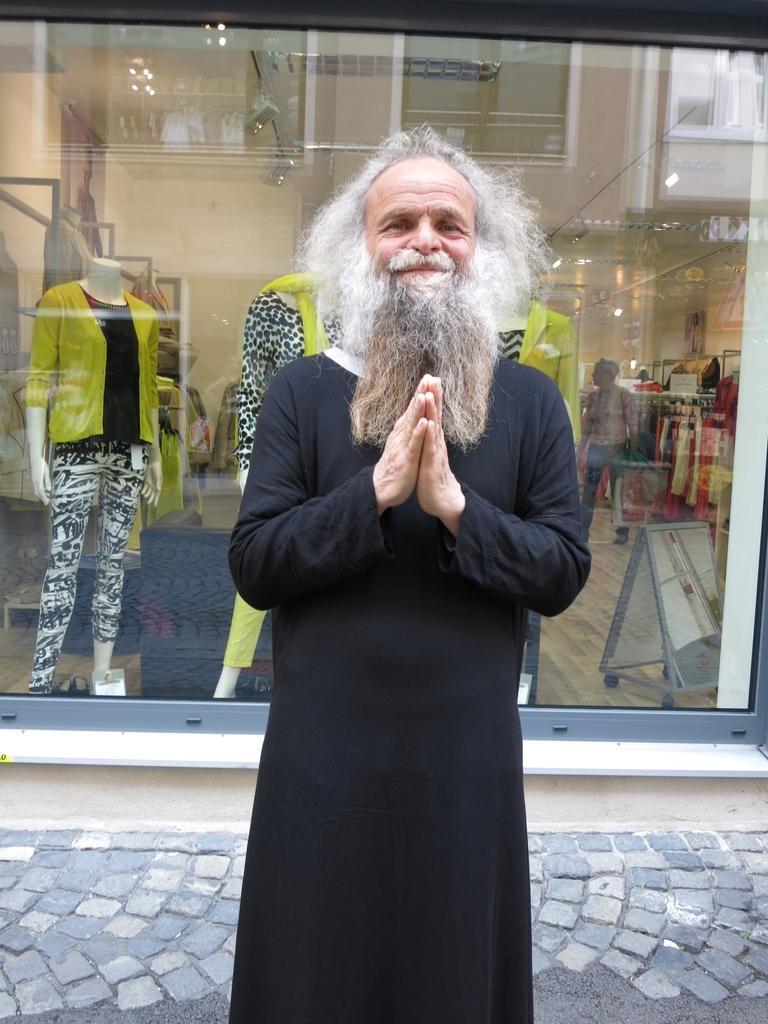Could you give a brief overview of what you see in this image? In this image, there are a few people. We can see some glass. We can see a few mannequins with clothes. We can see the ground with some objects. We can also see some clothes on the right. We can see some white colored poles. We can see the reflection on the glass. 